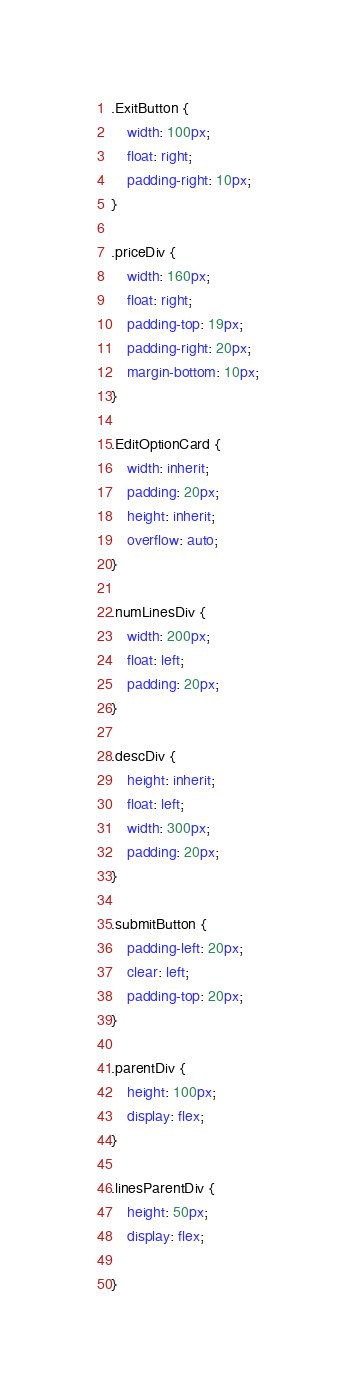Convert code to text. <code><loc_0><loc_0><loc_500><loc_500><_CSS_>.ExitButton {
    width: 100px;
    float: right;
    padding-right: 10px;
}

.priceDiv {
    width: 160px;
    float: right;
    padding-top: 19px;
    padding-right: 20px;
    margin-bottom: 10px;
}

.EditOptionCard {
    width: inherit;
    padding: 20px;
    height: inherit;
    overflow: auto;
}

.numLinesDiv {
    width: 200px;
    float: left;
    padding: 20px;
}

.descDiv {
    height: inherit;
    float: left;
    width: 300px;
    padding: 20px;
}

.submitButton {
    padding-left: 20px;
    clear: left;
    padding-top: 20px;
}

.parentDiv {
    height: 100px;
    display: flex;
}

.linesParentDiv {
    height: 50px;
    display: flex;

}
</code> 